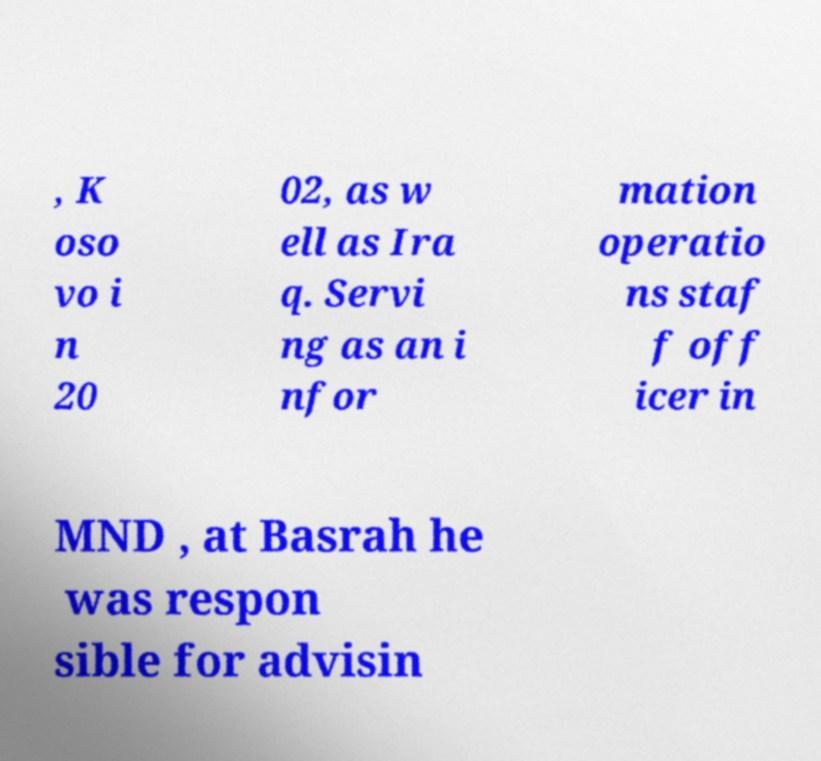I need the written content from this picture converted into text. Can you do that? , K oso vo i n 20 02, as w ell as Ira q. Servi ng as an i nfor mation operatio ns staf f off icer in MND , at Basrah he was respon sible for advisin 